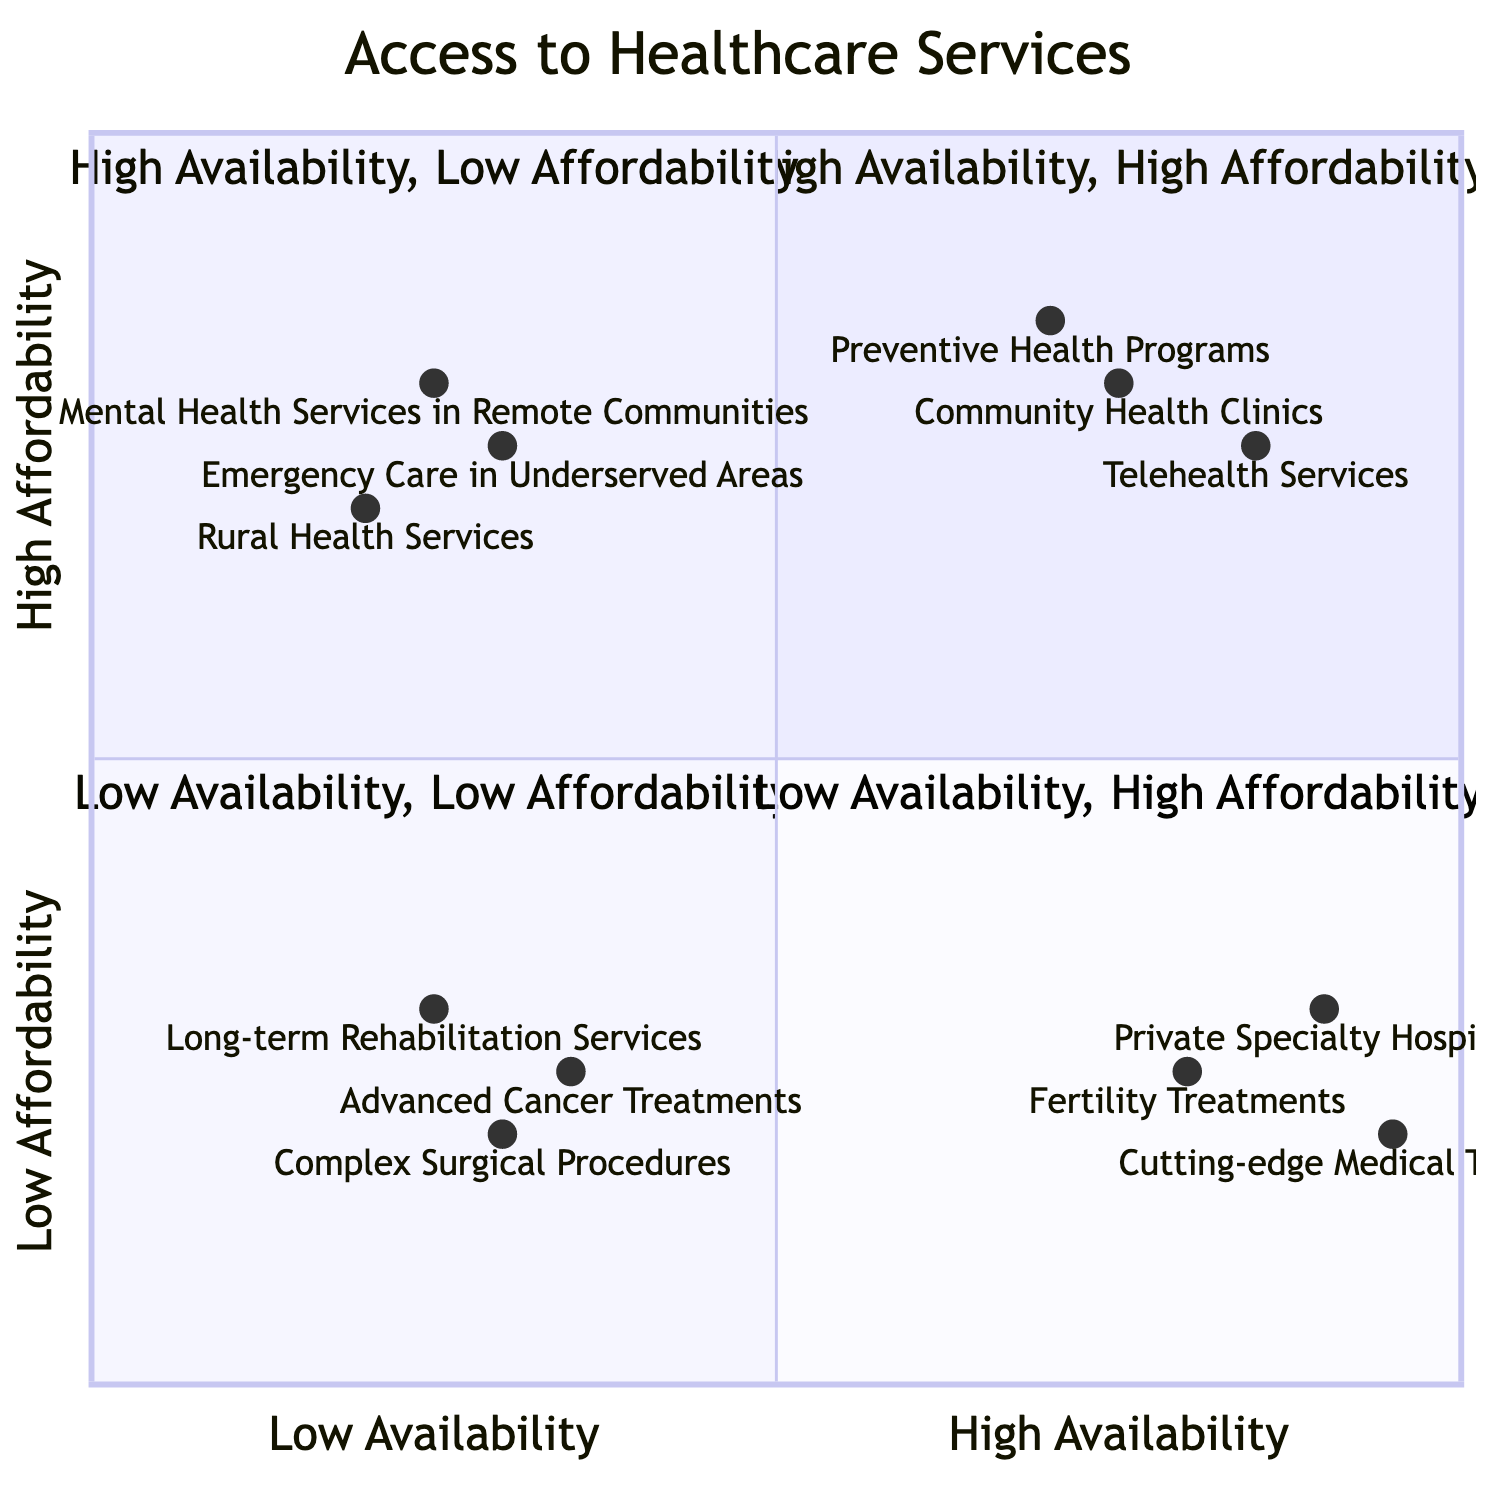What are the elements in the "High Availability, High Affordability" quadrant? The elements listed in the "High Availability, High Affordability" quadrant are found in the diagram's top-left section. These include Community Health Clinics, Telehealth Services, and Preventive Health Programs.
Answer: Community Health Clinics, Telehealth Services, Preventive Health Programs How many elements are located in the "Low Availability, Low Affordability" quadrant? The "Low Availability, Low Affordability" quadrant contains three elements as shown in the bottom-right section of the diagram: Complex Surgical Procedures, Advanced Cancer Treatments, and Long-term Rehabilitation Services.
Answer: 3 Which element has the highest affordability but low availability? In the quadrant located in the bottom-left section of the diagram, the only option with high affordability but low availability is Mental Health Services in Remote Communities as it is in the "Low Availability, High Affordability" quadrant.
Answer: Mental Health Services in Remote Communities What is the relationship between Private Specialty Hospitals and Community Health Clinics regarding availability? Private Specialty Hospitals, located in the "High Availability, Low Affordability" quadrant, have higher availability compared to Community Health Clinics, which are in the "High Availability, High Affordability" quadrant. Both are high in availability, but they differ in affordability.
Answer: Higher availability for both Which quadrant contains Emergency Care in Underserved Areas? Emergency Care in Underserved Areas is positioned within the "Low Availability, High Affordability" quadrant according to the diagram's spatial organization, located in the bottom-left section.
Answer: Low Availability, High Affordability How many elements are in the "High Availability, Low Affordability" quadrant compared to the "Low Availability, High Affordability" quadrant? The diagram shows that the "High Availability, Low Affordability" quadrant has three elements (Private Specialty Hospitals, Cutting-edge Medical Technologies, Fertility Treatments) while the "Low Availability, High Affordability" quadrant contains three elements (Rural Health Services, Emergency Care in Underserved Areas, Mental Health Services in Remote Communities), making them equal in quantity.
Answer: 3, 3 What can you conclude about the element with the greatest availability? The elements with the greatest availability all fall within the "High Availability, Low Affordability" quadrant, specifically Private Specialty Hospitals and Cutting-edge Medical Technologies, indicating they provide high service availability but are not affordable for everyone.
Answer: Private Specialty Hospitals, Cutting-edge Medical Technologies Which two quadrants have elements that are considered low affordability? The quadrants with elements that are low affordability are "High Availability, Low Affordability" and "Low Availability, Low Affordability," as evidenced by their elements.
Answer: High Availability, Low Affordability and Low Availability, Low Affordability 